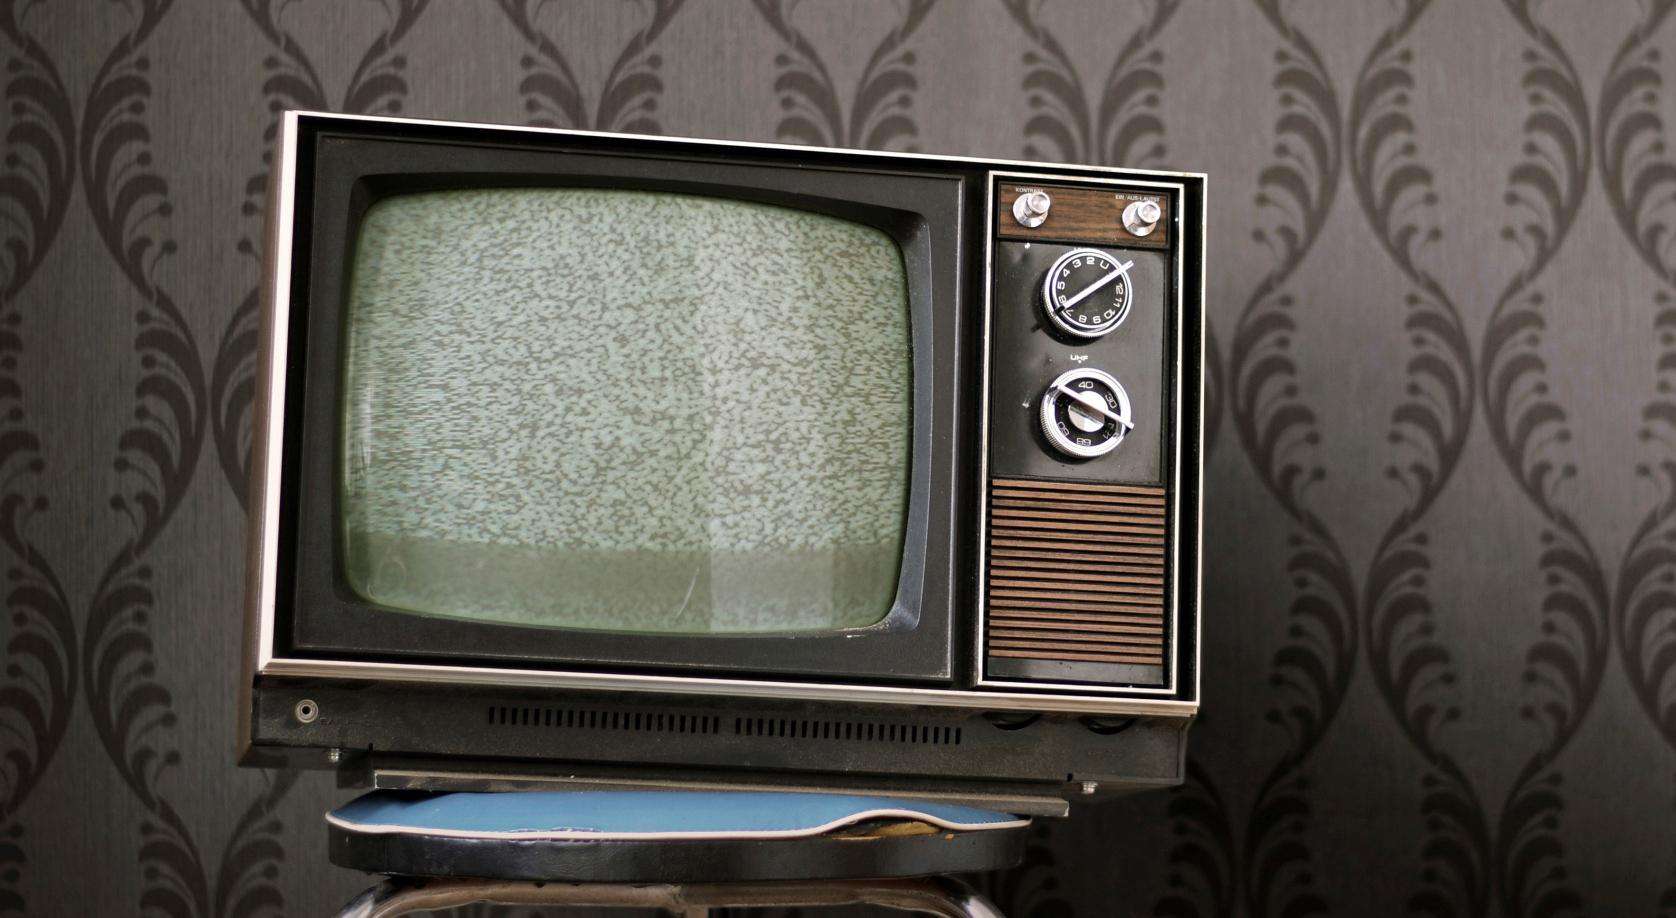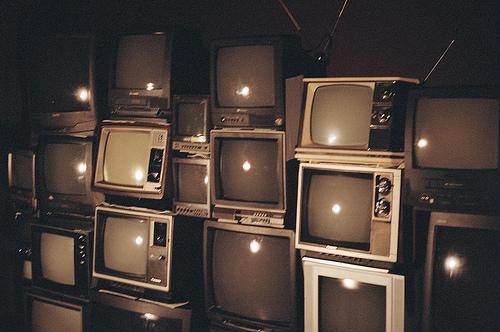The first image is the image on the left, the second image is the image on the right. For the images displayed, is the sentence "There is one tube type television in the image on the left." factually correct? Answer yes or no. Yes. The first image is the image on the left, the second image is the image on the right. Evaluate the accuracy of this statement regarding the images: "There is no more than one television in the left image.". Is it true? Answer yes or no. Yes. 